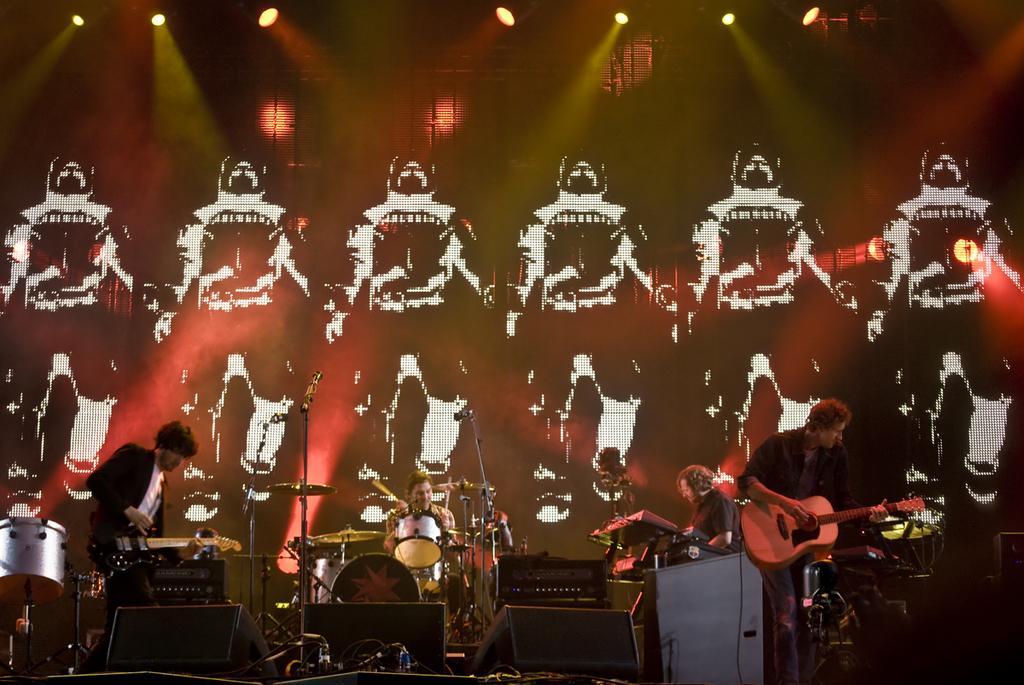Can you describe this image briefly? On the left and right side there are two person who are playing a guitar. In the middle there is a person who is sitting on the chair is playing a drum and some other musical instrument. There is an another person who is sitting on the right, who is playing a guitar. On the background we can see a screen which is showing mans cartoon. 